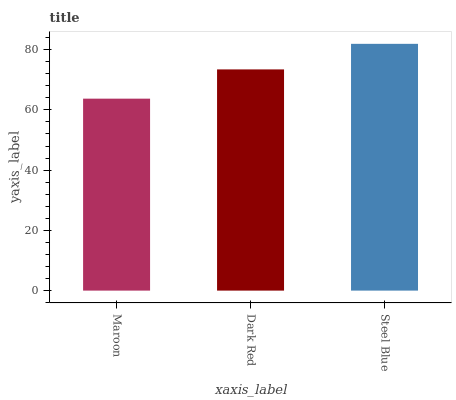Is Maroon the minimum?
Answer yes or no. Yes. Is Steel Blue the maximum?
Answer yes or no. Yes. Is Dark Red the minimum?
Answer yes or no. No. Is Dark Red the maximum?
Answer yes or no. No. Is Dark Red greater than Maroon?
Answer yes or no. Yes. Is Maroon less than Dark Red?
Answer yes or no. Yes. Is Maroon greater than Dark Red?
Answer yes or no. No. Is Dark Red less than Maroon?
Answer yes or no. No. Is Dark Red the high median?
Answer yes or no. Yes. Is Dark Red the low median?
Answer yes or no. Yes. Is Maroon the high median?
Answer yes or no. No. Is Maroon the low median?
Answer yes or no. No. 